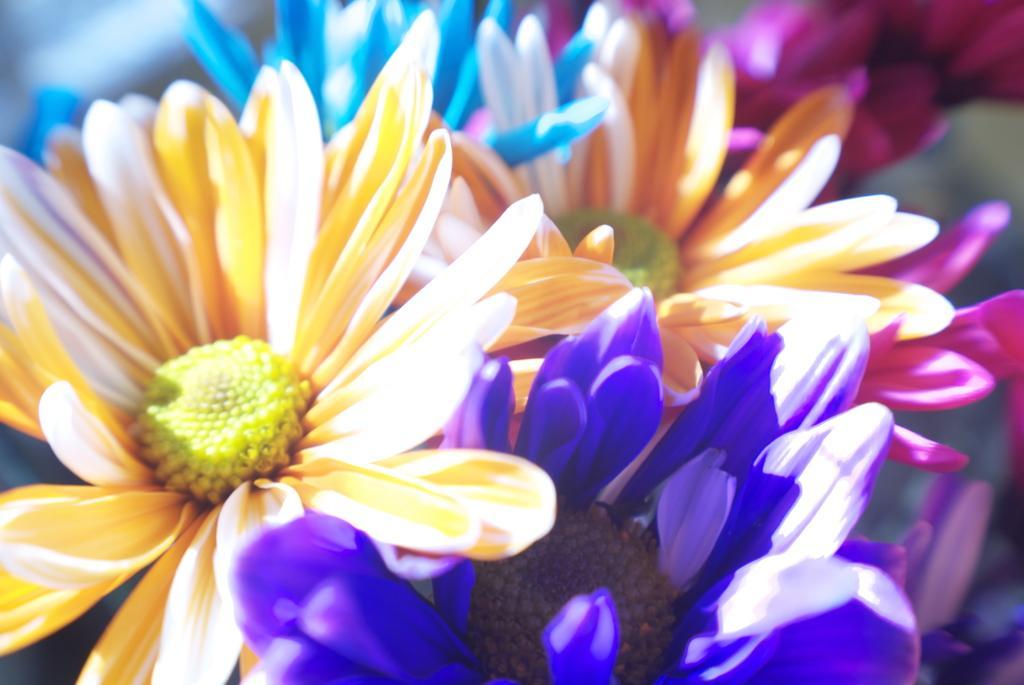Describe this image in one or two sentences. In this picture we can see different colors of flowers and in the background it is blurry. 